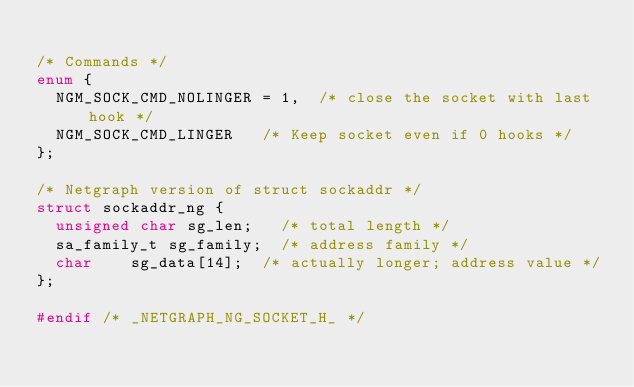Convert code to text. <code><loc_0><loc_0><loc_500><loc_500><_C_>
/* Commands */
enum {
	NGM_SOCK_CMD_NOLINGER = 1,	/* close the socket with last hook */
	NGM_SOCK_CMD_LINGER		/* Keep socket even if 0 hooks */
};

/* Netgraph version of struct sockaddr */
struct sockaddr_ng {
	unsigned char	sg_len;		/* total length */
	sa_family_t	sg_family;	/* address family */
	char		sg_data[14];	/* actually longer; address value */
};

#endif /* _NETGRAPH_NG_SOCKET_H_ */

</code> 